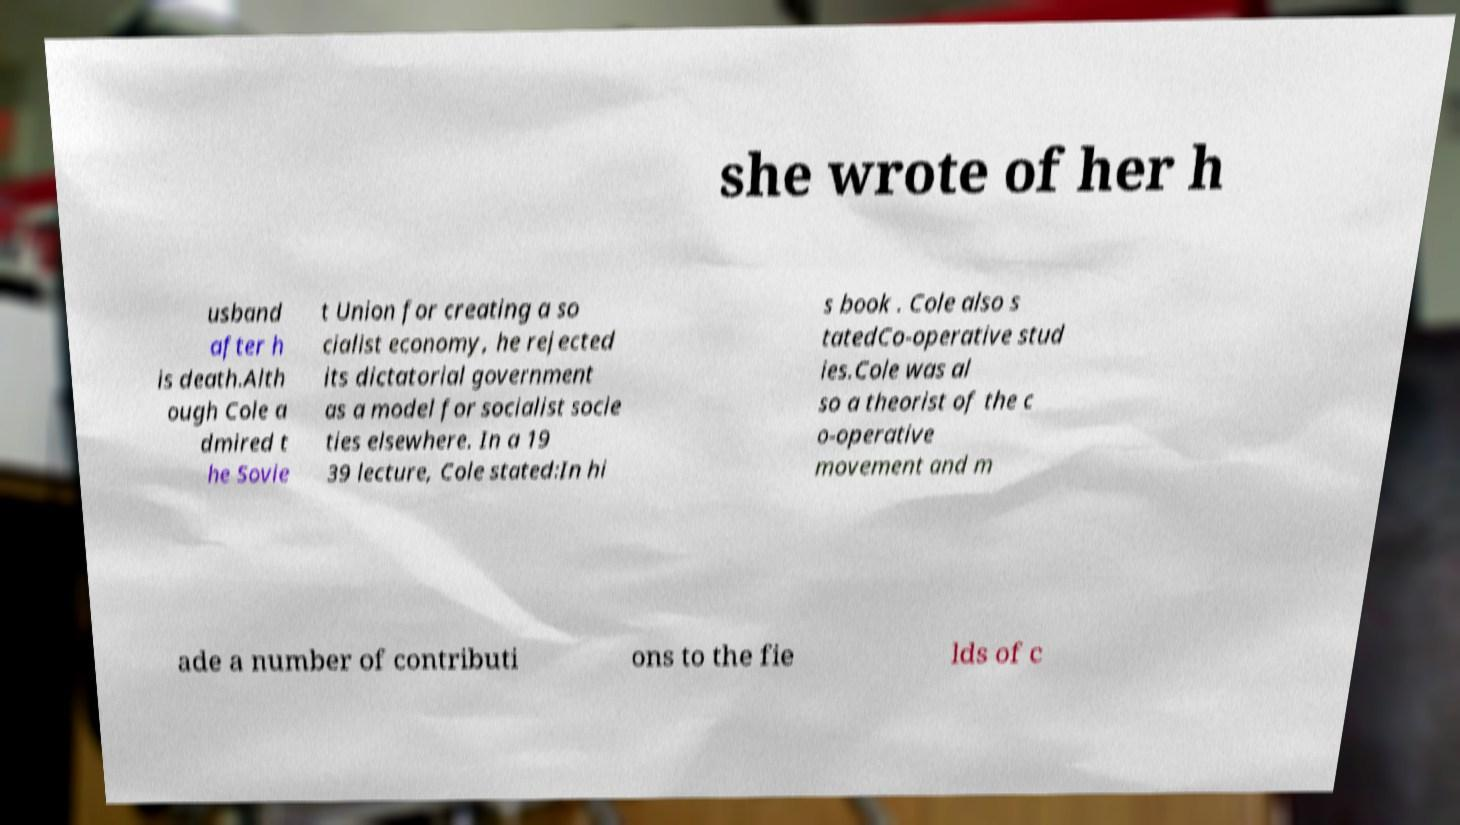Please identify and transcribe the text found in this image. she wrote of her h usband after h is death.Alth ough Cole a dmired t he Sovie t Union for creating a so cialist economy, he rejected its dictatorial government as a model for socialist socie ties elsewhere. In a 19 39 lecture, Cole stated:In hi s book . Cole also s tatedCo-operative stud ies.Cole was al so a theorist of the c o-operative movement and m ade a number of contributi ons to the fie lds of c 